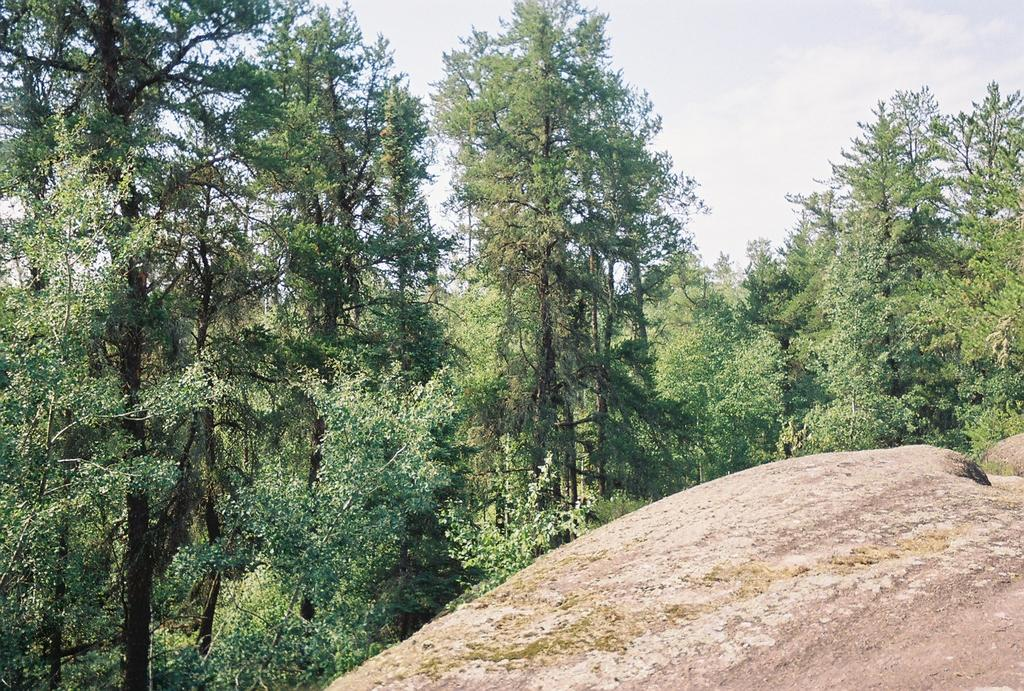What type of natural elements can be seen in the image? There are rocks in the image. What can be seen in the background of the image? There are many trees in the background of the image. What is visible at the top of the image? The sky is visible at the top of the image. What type of channel can be seen in the image? There is no channel present in the image; it features rocks and trees. Are there any books visible in the image? There are no books present in the image. 